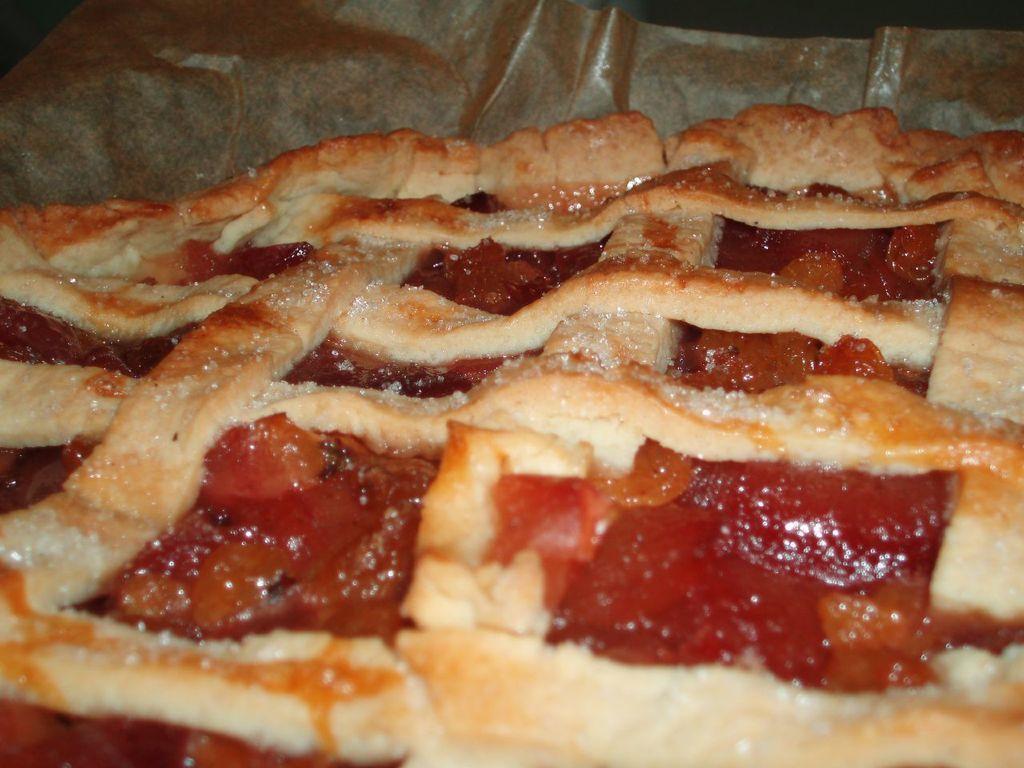Please provide a concise description of this image. In this image we can see some food. 